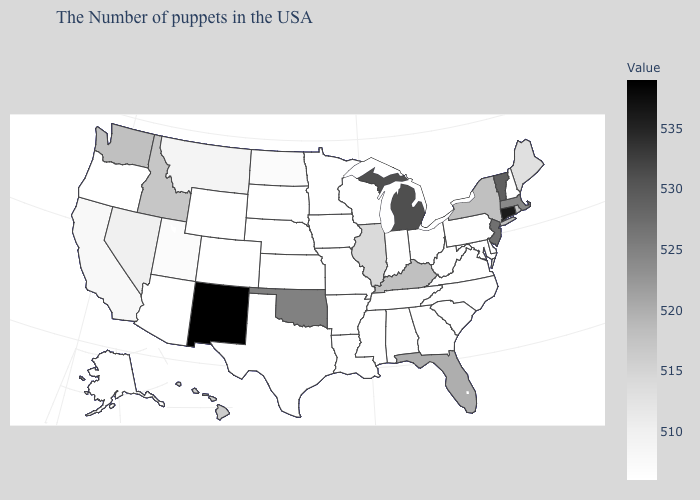Among the states that border Massachusetts , does New York have the highest value?
Concise answer only. No. Does Alaska have the highest value in the West?
Be succinct. No. Among the states that border Georgia , does Florida have the highest value?
Keep it brief. Yes. Does New Mexico have the highest value in the West?
Be succinct. Yes. Does North Dakota have a lower value than Rhode Island?
Write a very short answer. Yes. Among the states that border Massachusetts , which have the lowest value?
Write a very short answer. New Hampshire. Does Alaska have a higher value than Hawaii?
Give a very brief answer. No. Does the map have missing data?
Short answer required. No. 